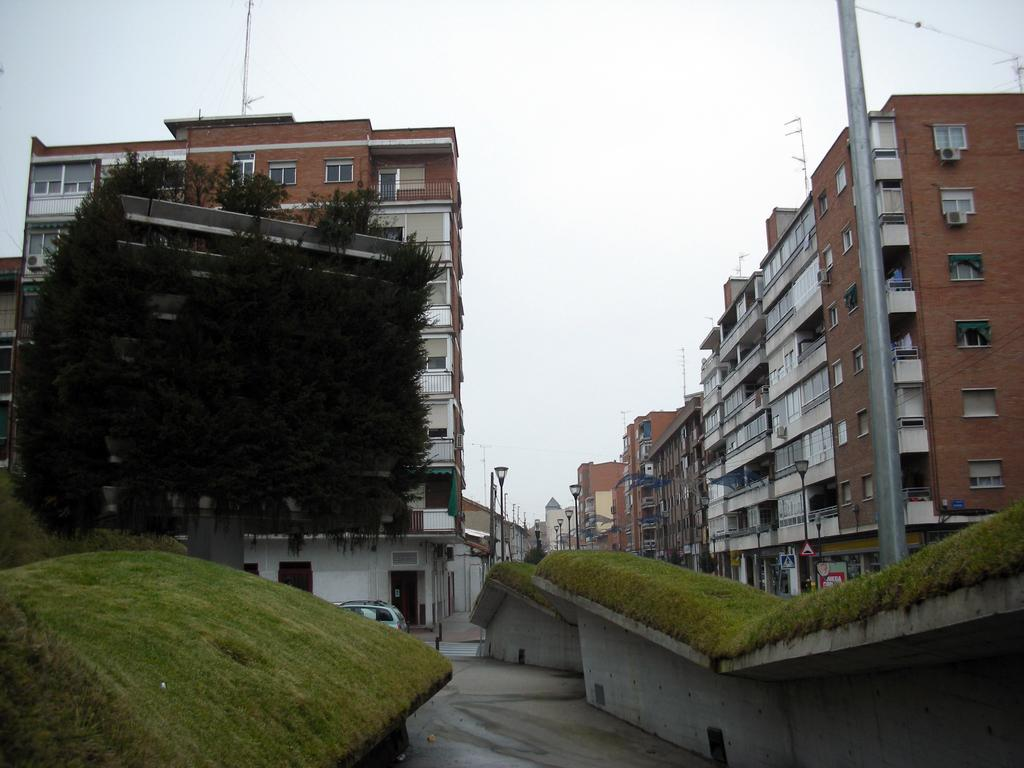What type of structures can be seen in the image? There are buildings in the image. What part of the buildings can be seen in the image? There are windows visible in the image. What other objects can be seen in the image? There are poles, trees, and light poles in the image. What is visible in the background of the image? The sky is visible in the image. What is present on the road in the image? There is a vehicle on the road in the image. What type of chair is depicted in the image? There is no chair present in the image. What theory can be observed being tested in the image? There is no theory being tested in the image; it features buildings, windows, poles, trees, light poles, the sky, and a vehicle on the road. 